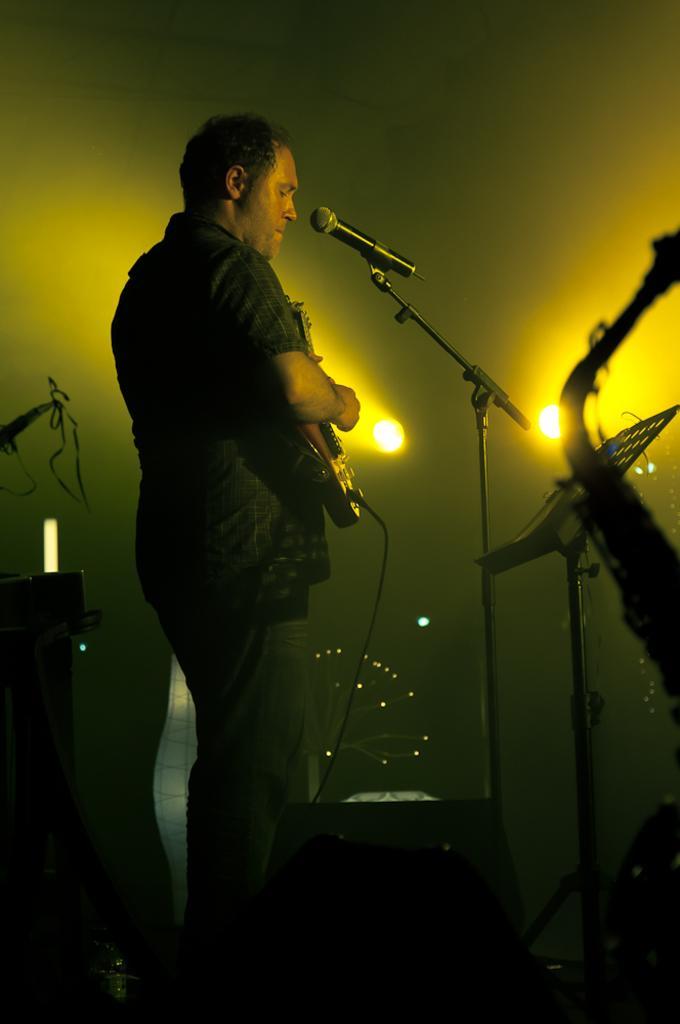Can you describe this image briefly? In this picture we can see a man who is standing in front of mike. He is playing guitar. On the background we can see a wall and these are the lights. 